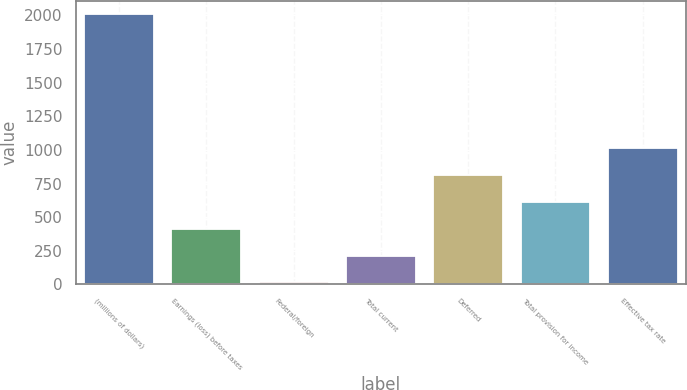Convert chart. <chart><loc_0><loc_0><loc_500><loc_500><bar_chart><fcel>(millions of dollars)<fcel>Earnings (loss) before taxes<fcel>Federal/foreign<fcel>Total current<fcel>Deferred<fcel>Total provision for income<fcel>Effective tax rate<nl><fcel>2010<fcel>413.2<fcel>14<fcel>213.6<fcel>812.4<fcel>612.8<fcel>1012<nl></chart> 